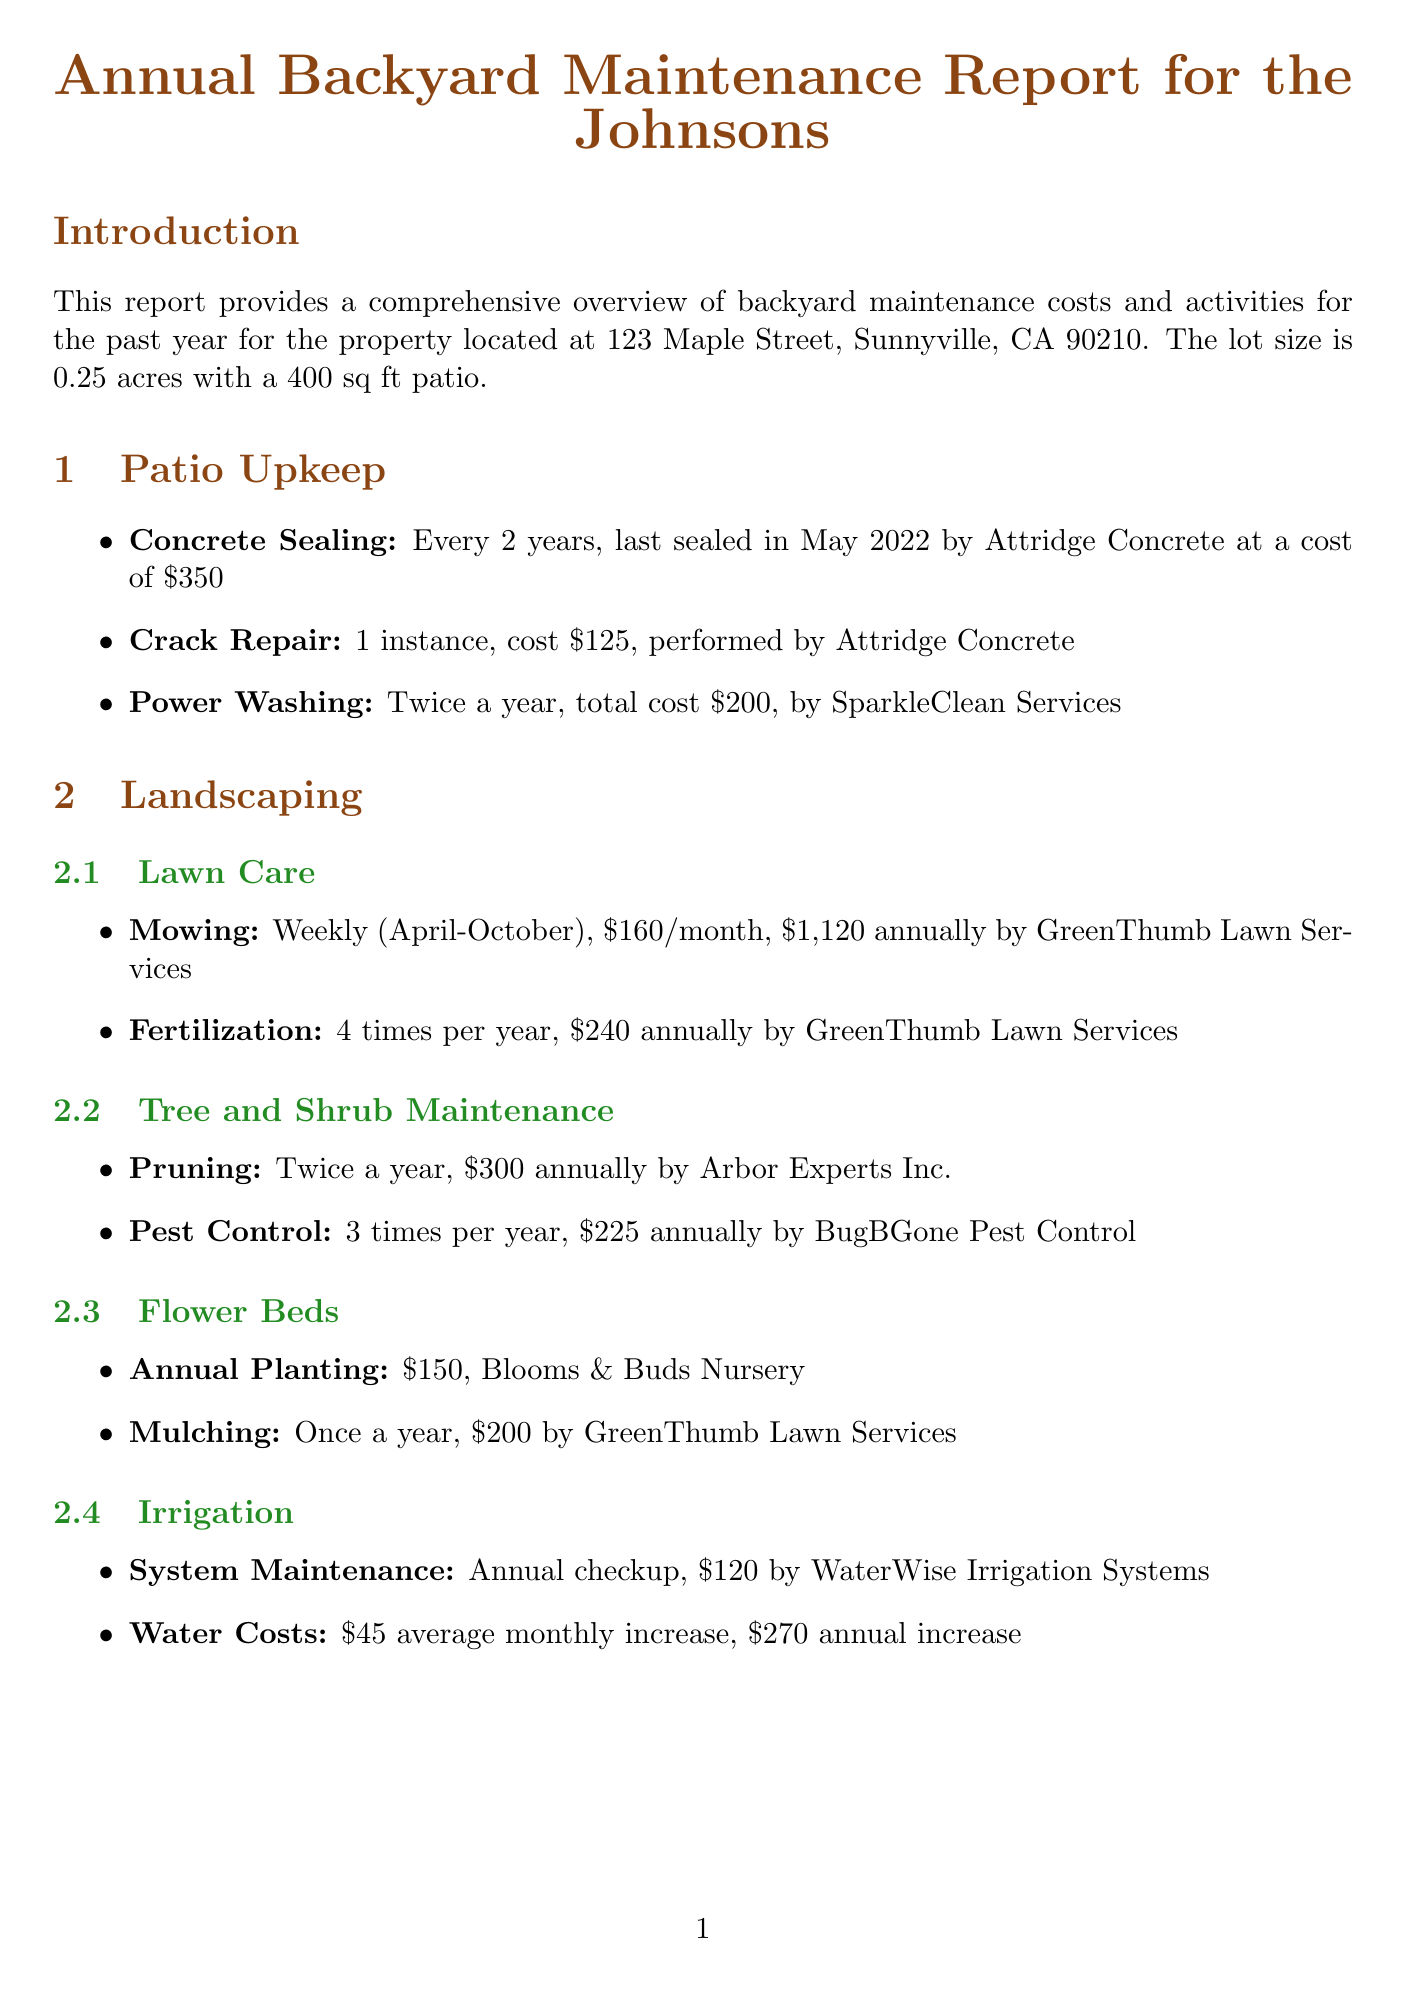What is the patio size? The patio size is mentioned under property details in the introduction section of the report, which states it is 400 sq ft.
Answer: 400 sq ft What is the cost of concrete sealing? The cost of concrete sealing is found in the patio upkeep section, where it states it costs $350.
Answer: $350 How often is lawn mowing performed? The lawn care section indicates that mowing is done weekly from April to October.
Answer: Weekly (April-October) What is the annual cost for landscaping? The document summarizes the landscaping costs in the annual cost summary section, indicating that it totals $2,825.
Answer: $2,825 How many times is grill cleaning done each year? The BBQ area maintenance section states that grill cleaning is performed 4 times per year.
Answer: 4 times What is the last replacement date for the cushion? The document mentions that the last cushion replacement was in June 2021 in the BBQ area maintenance section.
Answer: June 2021 What recommendation is made regarding water costs? The recommendations section suggests considering installing drought-resistant plants to reduce water costs.
Answer: Install drought-resistant plants What is the total annual cost for the backyard maintenance? The total annual cost is listed in the annual cost summary section as $3,775.
Answer: $3,775 How often should the concrete sealing be scheduled? The report states that concrete sealing should be scheduled every 2 years, with the next due in May 2024.
Answer: Every 2 years 